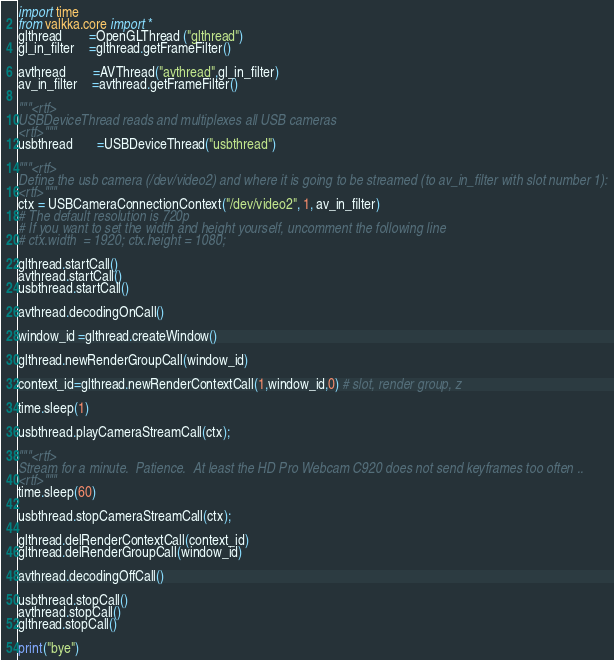Convert code to text. <code><loc_0><loc_0><loc_500><loc_500><_Python_>import time
from valkka.core import *
glthread        =OpenGLThread ("glthread")
gl_in_filter    =glthread.getFrameFilter()

avthread        =AVThread("avthread",gl_in_filter)
av_in_filter    =avthread.getFrameFilter()

"""<rtf>
USBDeviceThread reads and multiplexes all USB cameras
<rtf>"""
usbthread       =USBDeviceThread("usbthread")

"""<rtf>
Define the usb camera (/dev/video2) and where it is going to be streamed (to av_in_filter with slot number 1):
<rtf>"""
ctx = USBCameraConnectionContext("/dev/video2", 1, av_in_filter)
# The default resolution is 720p 
# If you want to set the width and height yourself, uncomment the following line
# ctx.width  = 1920; ctx.height = 1080;
  
glthread.startCall()
avthread.startCall()
usbthread.startCall()

avthread.decodingOnCall()

window_id =glthread.createWindow()

glthread.newRenderGroupCall(window_id)

context_id=glthread.newRenderContextCall(1,window_id,0) # slot, render group, z

time.sleep(1)

usbthread.playCameraStreamCall(ctx);

"""<rtf>
Stream for a minute.  Patience.  At least the HD Pro Webcam C920 does not send keyframes too often ..
<rtf>"""
time.sleep(60)

usbthread.stopCameraStreamCall(ctx);

glthread.delRenderContextCall(context_id)
glthread.delRenderGroupCall(window_id)

avthread.decodingOffCall()

usbthread.stopCall()
avthread.stopCall()
glthread.stopCall()

print("bye")
</code> 